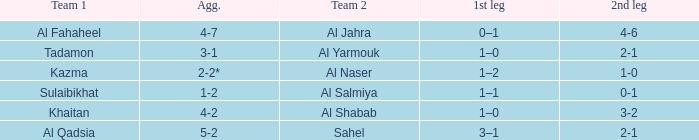What is the 1st leg of the Al Fahaheel Team 1? 0–1. 